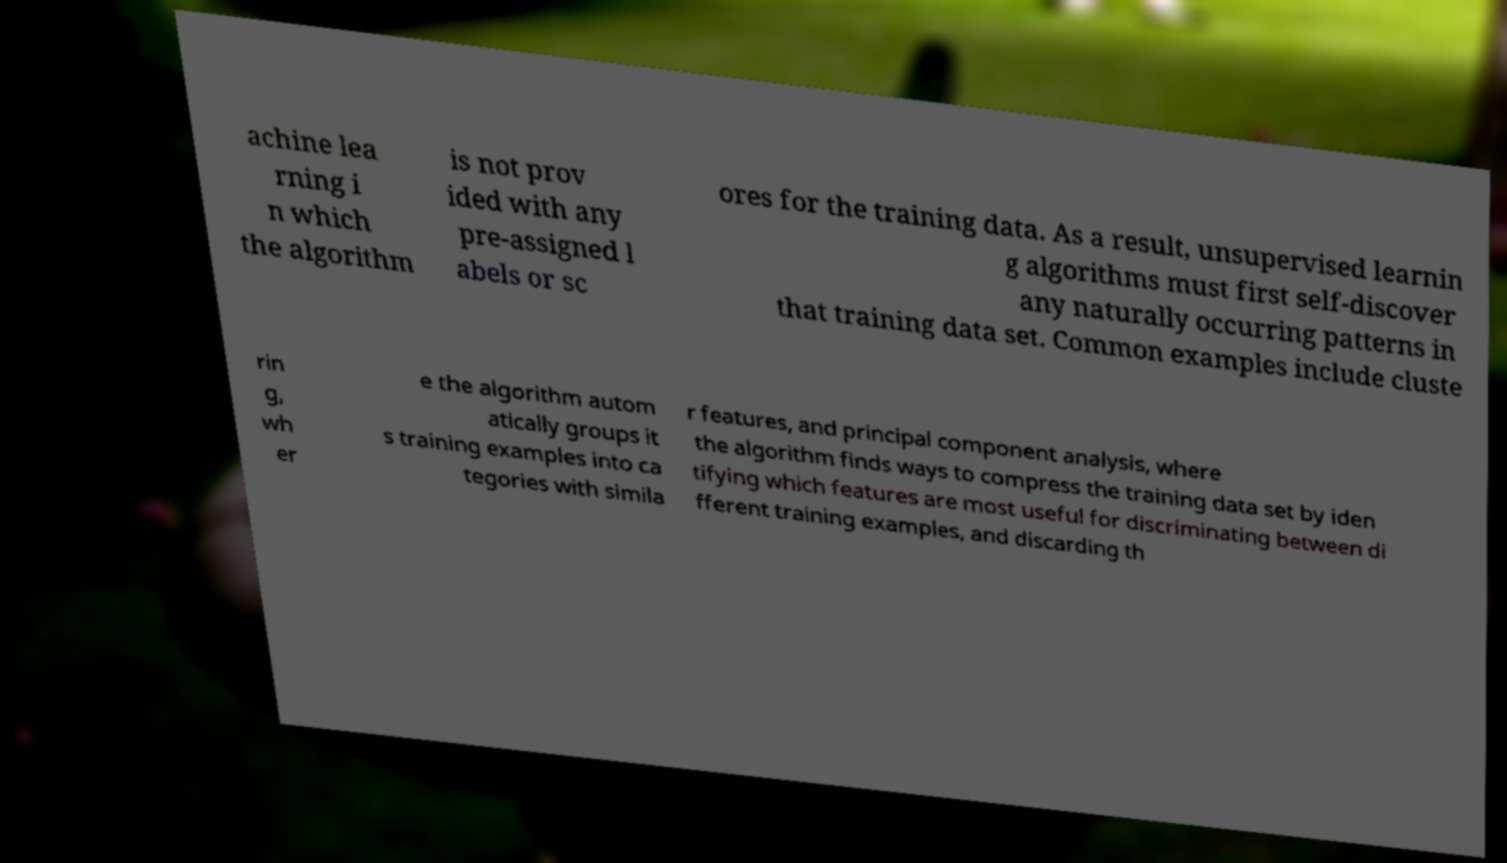What messages or text are displayed in this image? I need them in a readable, typed format. achine lea rning i n which the algorithm is not prov ided with any pre-assigned l abels or sc ores for the training data. As a result, unsupervised learnin g algorithms must first self-discover any naturally occurring patterns in that training data set. Common examples include cluste rin g, wh er e the algorithm autom atically groups it s training examples into ca tegories with simila r features, and principal component analysis, where the algorithm finds ways to compress the training data set by iden tifying which features are most useful for discriminating between di fferent training examples, and discarding th 